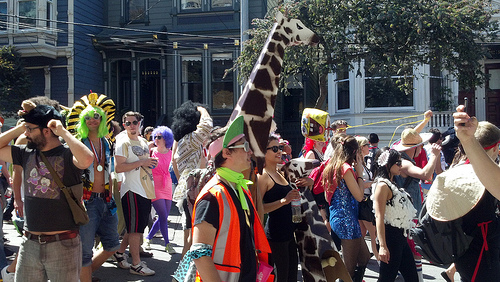<image>
Can you confirm if the headdress guy is in front of the giraffe guy? No. The headdress guy is not in front of the giraffe guy. The spatial positioning shows a different relationship between these objects. 